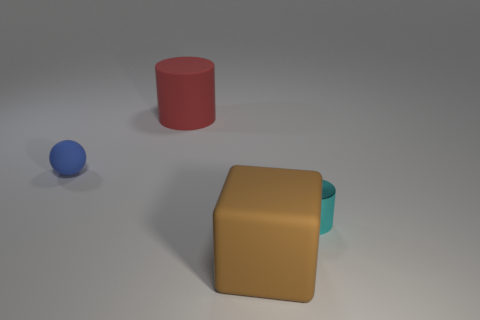Is there any other thing that has the same material as the cyan cylinder?
Give a very brief answer. No. Are there any large brown matte objects that are to the left of the small thing that is in front of the small object that is left of the large rubber cylinder?
Provide a succinct answer. Yes. There is a tiny sphere that is made of the same material as the big red cylinder; what color is it?
Offer a terse response. Blue. How many red objects are made of the same material as the small cylinder?
Your answer should be compact. 0. Is the material of the large brown block the same as the thing right of the big brown rubber object?
Give a very brief answer. No. What number of things are large objects that are in front of the small cyan metallic object or rubber spheres?
Your response must be concise. 2. There is a rubber object that is on the right side of the cylinder left of the big rubber object in front of the red matte cylinder; what is its size?
Offer a very short reply. Large. Are there any other things that have the same shape as the big brown object?
Your answer should be compact. No. How big is the object that is in front of the tiny thing that is in front of the small rubber object?
Make the answer very short. Large. What number of large objects are either yellow metallic balls or shiny objects?
Offer a very short reply. 0. 